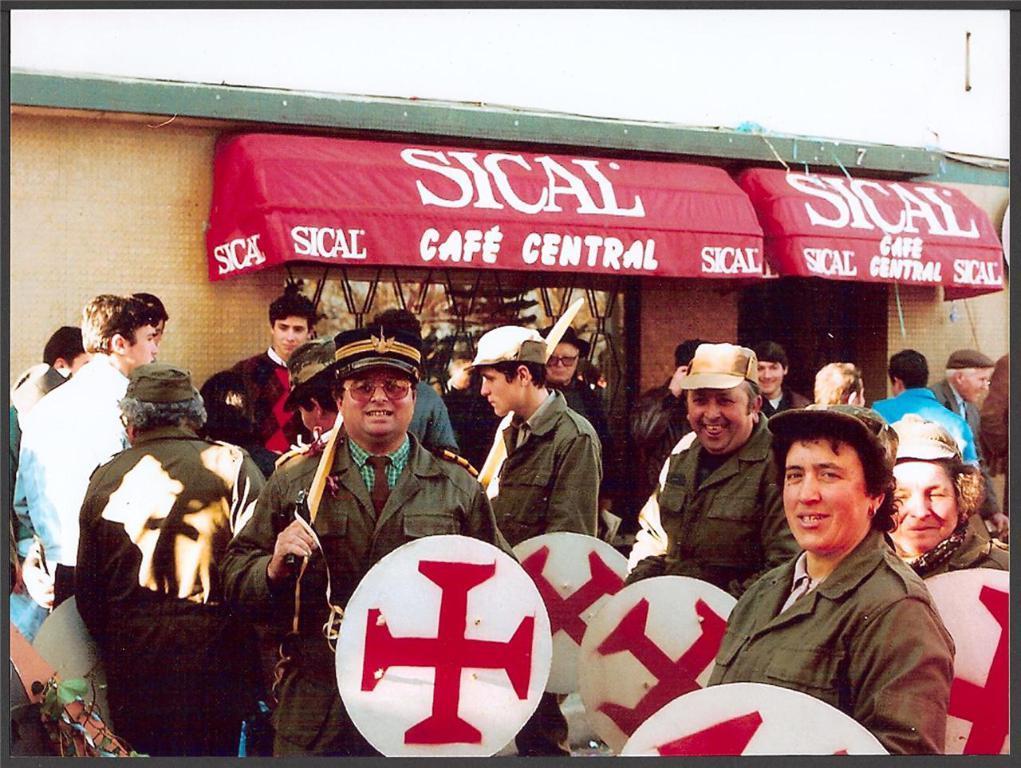Describe this image in one or two sentences. In the foreground of the picture there are people holding shields and swords. In the center of the picture there are people standing near a cafe. At the top there are banners and a building. 